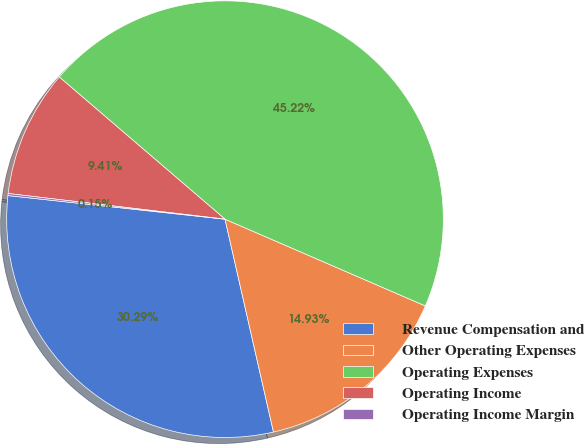<chart> <loc_0><loc_0><loc_500><loc_500><pie_chart><fcel>Revenue Compensation and<fcel>Other Operating Expenses<fcel>Operating Expenses<fcel>Operating Income<fcel>Operating Income Margin<nl><fcel>30.29%<fcel>14.93%<fcel>45.22%<fcel>9.41%<fcel>0.15%<nl></chart> 